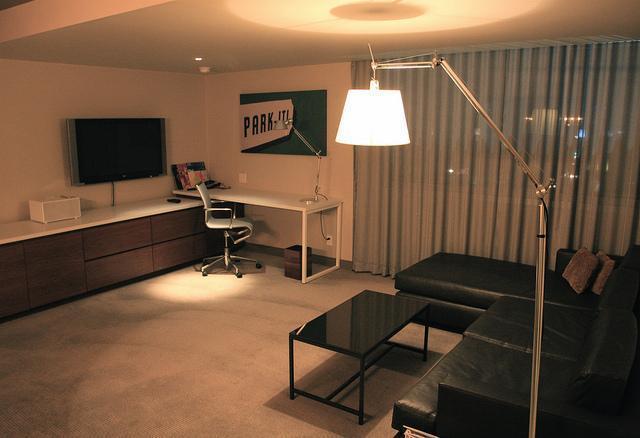How many people are standing wearing blue?
Give a very brief answer. 0. 